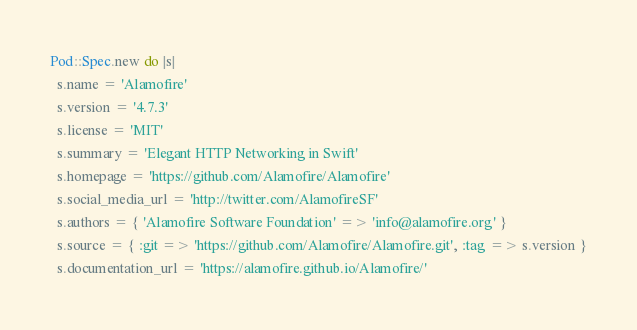Convert code to text. <code><loc_0><loc_0><loc_500><loc_500><_Ruby_>Pod::Spec.new do |s|
  s.name = 'Alamofire'
  s.version = '4.7.3'
  s.license = 'MIT'
  s.summary = 'Elegant HTTP Networking in Swift'
  s.homepage = 'https://github.com/Alamofire/Alamofire'
  s.social_media_url = 'http://twitter.com/AlamofireSF'
  s.authors = { 'Alamofire Software Foundation' => 'info@alamofire.org' }
  s.source = { :git => 'https://github.com/Alamofire/Alamofire.git', :tag => s.version }
  s.documentation_url = 'https://alamofire.github.io/Alamofire/'
</code> 